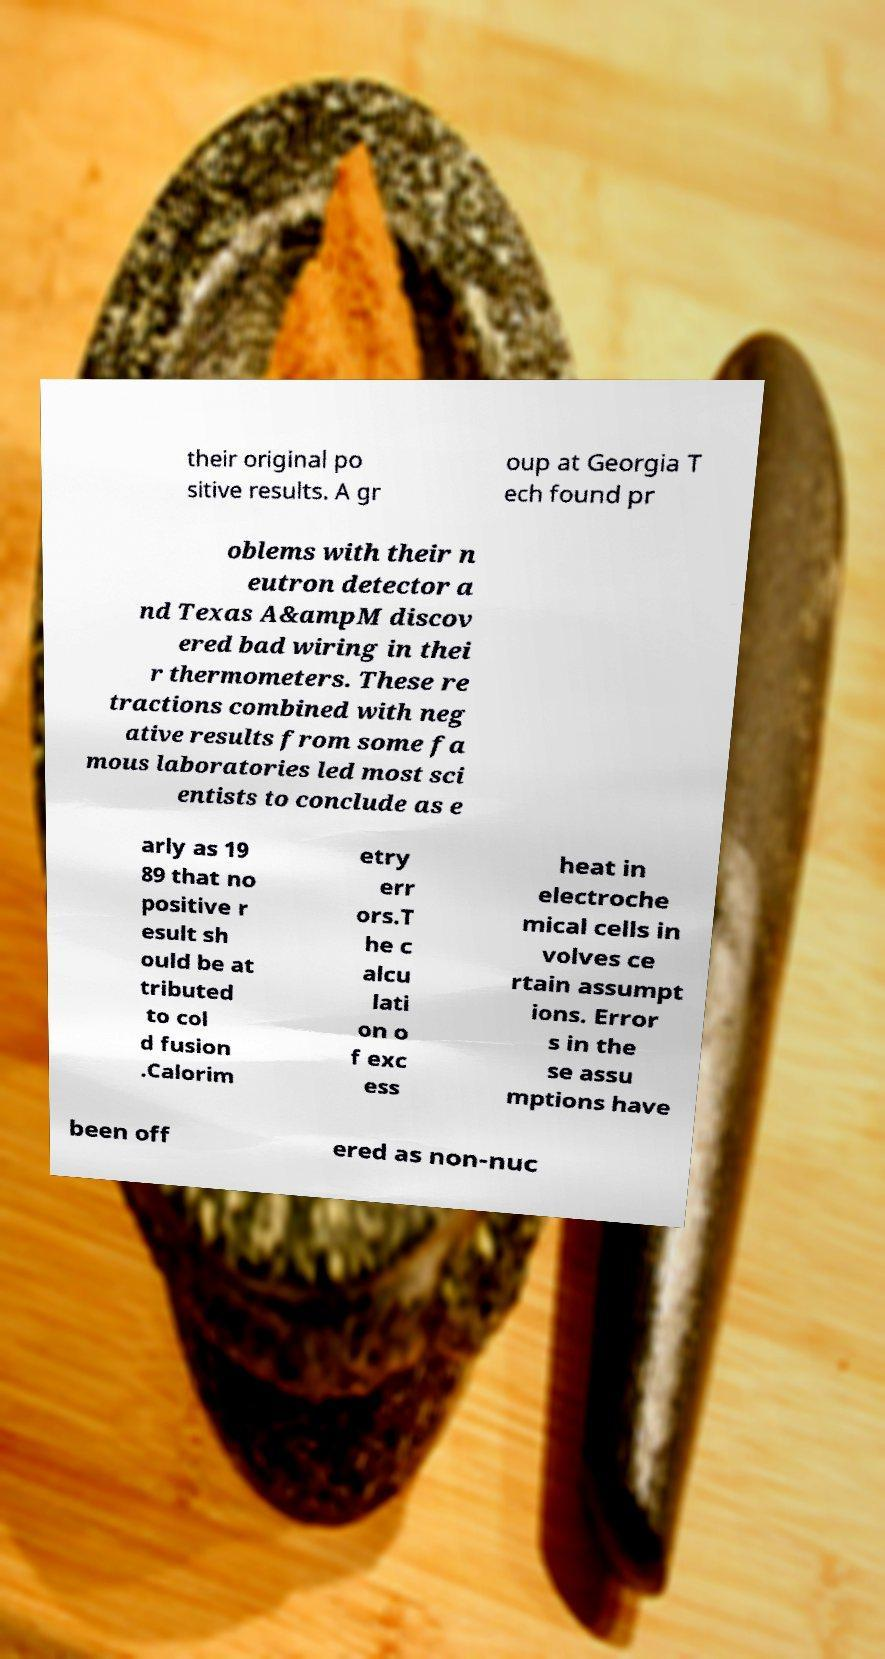Can you read and provide the text displayed in the image?This photo seems to have some interesting text. Can you extract and type it out for me? their original po sitive results. A gr oup at Georgia T ech found pr oblems with their n eutron detector a nd Texas A&ampM discov ered bad wiring in thei r thermometers. These re tractions combined with neg ative results from some fa mous laboratories led most sci entists to conclude as e arly as 19 89 that no positive r esult sh ould be at tributed to col d fusion .Calorim etry err ors.T he c alcu lati on o f exc ess heat in electroche mical cells in volves ce rtain assumpt ions. Error s in the se assu mptions have been off ered as non-nuc 